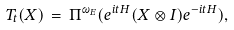<formula> <loc_0><loc_0><loc_500><loc_500>T _ { t } ( X ) \, = \, \Pi ^ { \omega _ { E } } ( e ^ { i t H } ( X \otimes I ) e ^ { - i t H } ) ,</formula> 